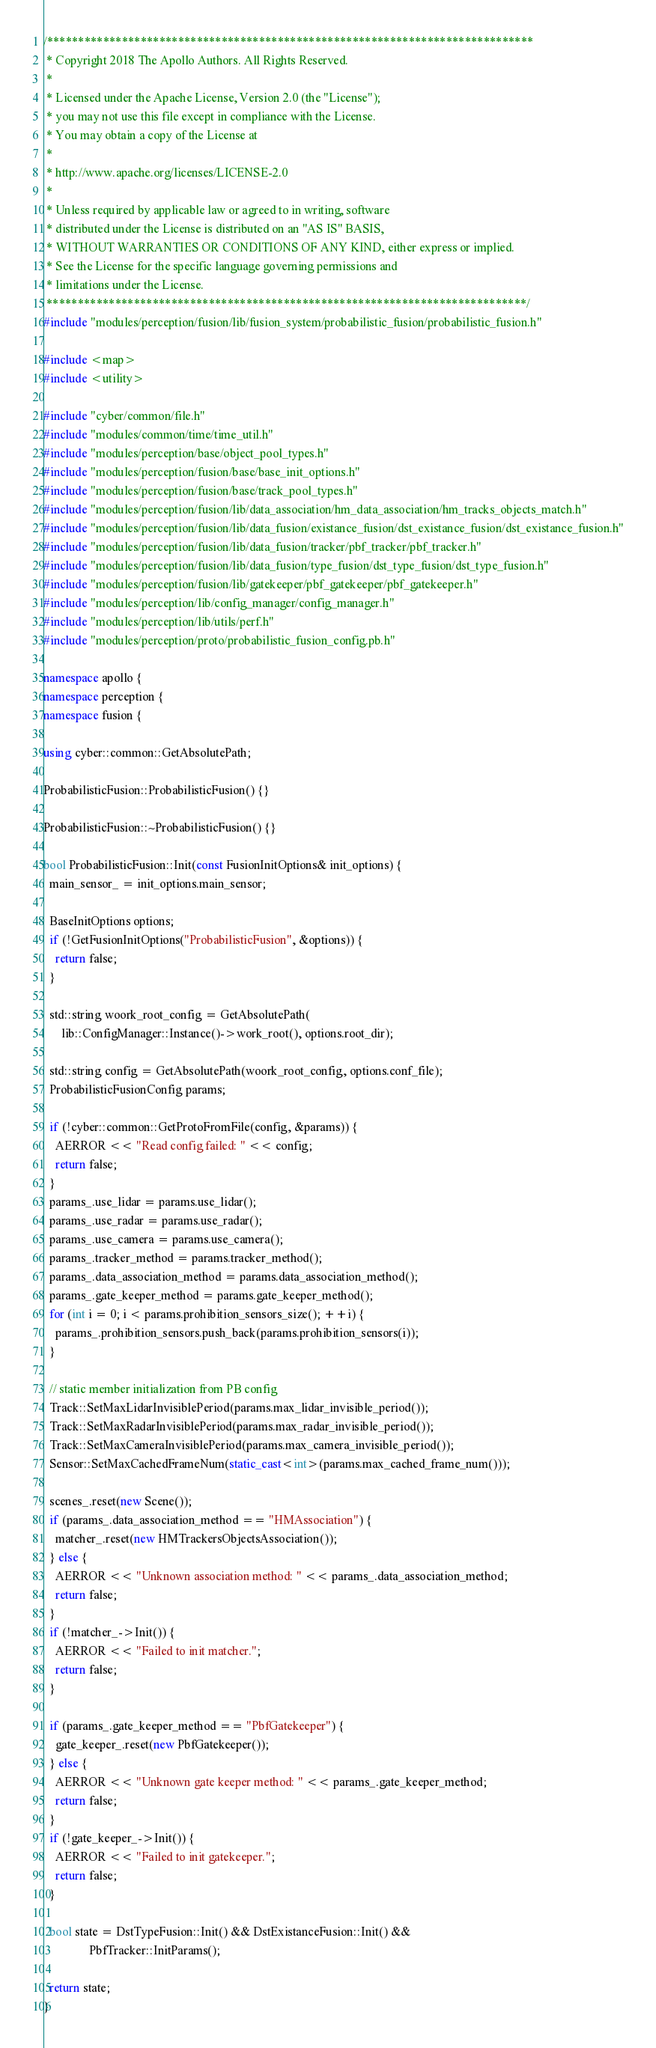Convert code to text. <code><loc_0><loc_0><loc_500><loc_500><_C++_>/******************************************************************************
 * Copyright 2018 The Apollo Authors. All Rights Reserved.
 *
 * Licensed under the Apache License, Version 2.0 (the "License");
 * you may not use this file except in compliance with the License.
 * You may obtain a copy of the License at
 *
 * http://www.apache.org/licenses/LICENSE-2.0
 *
 * Unless required by applicable law or agreed to in writing, software
 * distributed under the License is distributed on an "AS IS" BASIS,
 * WITHOUT WARRANTIES OR CONDITIONS OF ANY KIND, either express or implied.
 * See the License for the specific language governing permissions and
 * limitations under the License.
 *****************************************************************************/
#include "modules/perception/fusion/lib/fusion_system/probabilistic_fusion/probabilistic_fusion.h"

#include <map>
#include <utility>

#include "cyber/common/file.h"
#include "modules/common/time/time_util.h"
#include "modules/perception/base/object_pool_types.h"
#include "modules/perception/fusion/base/base_init_options.h"
#include "modules/perception/fusion/base/track_pool_types.h"
#include "modules/perception/fusion/lib/data_association/hm_data_association/hm_tracks_objects_match.h"
#include "modules/perception/fusion/lib/data_fusion/existance_fusion/dst_existance_fusion/dst_existance_fusion.h"
#include "modules/perception/fusion/lib/data_fusion/tracker/pbf_tracker/pbf_tracker.h"
#include "modules/perception/fusion/lib/data_fusion/type_fusion/dst_type_fusion/dst_type_fusion.h"
#include "modules/perception/fusion/lib/gatekeeper/pbf_gatekeeper/pbf_gatekeeper.h"
#include "modules/perception/lib/config_manager/config_manager.h"
#include "modules/perception/lib/utils/perf.h"
#include "modules/perception/proto/probabilistic_fusion_config.pb.h"

namespace apollo {
namespace perception {
namespace fusion {

using cyber::common::GetAbsolutePath;

ProbabilisticFusion::ProbabilisticFusion() {}

ProbabilisticFusion::~ProbabilisticFusion() {}

bool ProbabilisticFusion::Init(const FusionInitOptions& init_options) {
  main_sensor_ = init_options.main_sensor;

  BaseInitOptions options;
  if (!GetFusionInitOptions("ProbabilisticFusion", &options)) {
    return false;
  }

  std::string woork_root_config = GetAbsolutePath(
      lib::ConfigManager::Instance()->work_root(), options.root_dir);

  std::string config = GetAbsolutePath(woork_root_config, options.conf_file);
  ProbabilisticFusionConfig params;

  if (!cyber::common::GetProtoFromFile(config, &params)) {
    AERROR << "Read config failed: " << config;
    return false;
  }
  params_.use_lidar = params.use_lidar();
  params_.use_radar = params.use_radar();
  params_.use_camera = params.use_camera();
  params_.tracker_method = params.tracker_method();
  params_.data_association_method = params.data_association_method();
  params_.gate_keeper_method = params.gate_keeper_method();
  for (int i = 0; i < params.prohibition_sensors_size(); ++i) {
    params_.prohibition_sensors.push_back(params.prohibition_sensors(i));
  }

  // static member initialization from PB config
  Track::SetMaxLidarInvisiblePeriod(params.max_lidar_invisible_period());
  Track::SetMaxRadarInvisiblePeriod(params.max_radar_invisible_period());
  Track::SetMaxCameraInvisiblePeriod(params.max_camera_invisible_period());
  Sensor::SetMaxCachedFrameNum(static_cast<int>(params.max_cached_frame_num()));

  scenes_.reset(new Scene());
  if (params_.data_association_method == "HMAssociation") {
    matcher_.reset(new HMTrackersObjectsAssociation());
  } else {
    AERROR << "Unknown association method: " << params_.data_association_method;
    return false;
  }
  if (!matcher_->Init()) {
    AERROR << "Failed to init matcher.";
    return false;
  }

  if (params_.gate_keeper_method == "PbfGatekeeper") {
    gate_keeper_.reset(new PbfGatekeeper());
  } else {
    AERROR << "Unknown gate keeper method: " << params_.gate_keeper_method;
    return false;
  }
  if (!gate_keeper_->Init()) {
    AERROR << "Failed to init gatekeeper.";
    return false;
  }

  bool state = DstTypeFusion::Init() && DstExistanceFusion::Init() &&
               PbfTracker::InitParams();

  return state;
}
</code> 